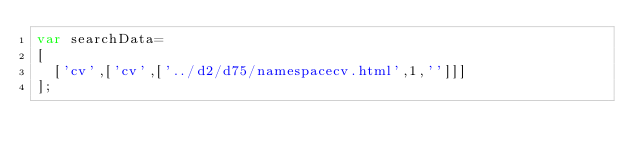Convert code to text. <code><loc_0><loc_0><loc_500><loc_500><_JavaScript_>var searchData=
[
  ['cv',['cv',['../d2/d75/namespacecv.html',1,'']]]
];
</code> 